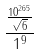Convert formula to latex. <formula><loc_0><loc_0><loc_500><loc_500>\frac { \frac { 1 0 ^ { 2 6 5 } } { \sqrt { 6 } } } { 1 ^ { 9 } }</formula> 